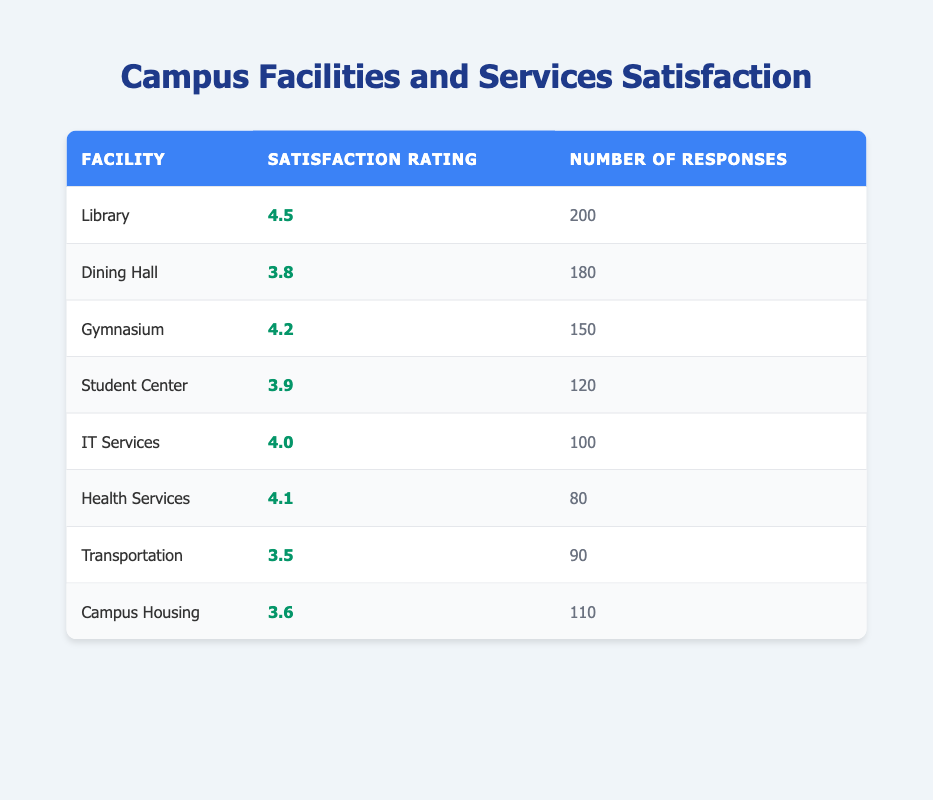What is the satisfaction rating for the Library? The satisfaction rating for the Library is directly listed in the table under the "Satisfaction Rating" column.
Answer: 4.5 Which facility received the lowest satisfaction rating? To find the lowest rating, I examine the satisfaction ratings from all facilities. The Transportation facility has the lowest satisfaction rating at 3.5.
Answer: Transportation What is the total number of responses received for the Gymnasium and Dining Hall? I add the number of responses for both the Gymnasium (150) and the Dining Hall (180). Thus, 150 + 180 = 330.
Answer: 330 Is the satisfaction rating for IT Services higher than that for Health Services? The satisfaction rating for IT Services is 4.0, and for Health Services, it is 4.1. Since 4.0 is less than 4.1, the statement is false.
Answer: No What is the average satisfaction rating for all the facilities combined? I sum the satisfaction ratings (4.5 + 3.8 + 4.2 + 3.9 + 4.0 + 4.1 + 3.5 + 3.6 = 32.6) and divide by the number of facilities (8). Therefore, the average rating is 32.6 / 8 = 4.075.
Answer: 4.075 How many more responses did the Library receive compared to Health Services? The Library received 200 responses while Health Services received 80 responses. The difference is 200 - 80 = 120.
Answer: 120 Which facilities have a satisfaction rating of 4.0 or higher? I check the satisfaction ratings of each facility. The Library (4.5), Gymnasium (4.2), IT Services (4.0), and Health Services (4.1) all have ratings of 4.0 or higher.
Answer: Library, Gymnasium, IT Services, Health Services Is there a correlation between the number of responses and satisfaction ratings? To determine correlation, I compare the two columns. While there is some variation, without performing a statistical analysis, it's hard to definitively say there's a strong correlation just by observation.
Answer: Undetermined 